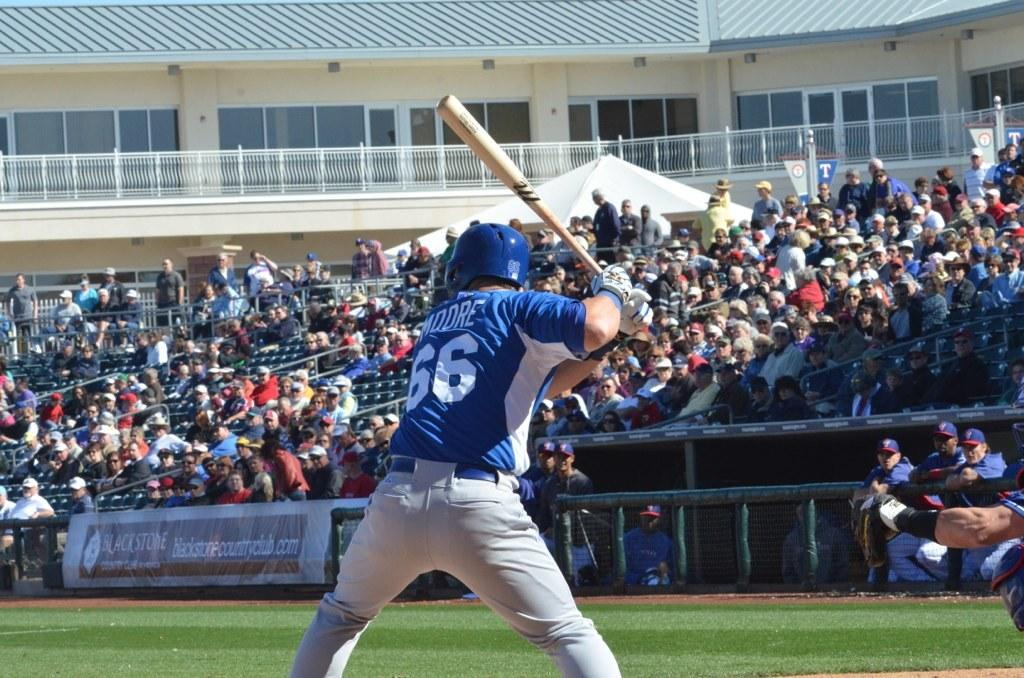Provide a one-sentence caption for the provided image. baseball player #66 named Moore is at bat in front of crowd in the stands. 